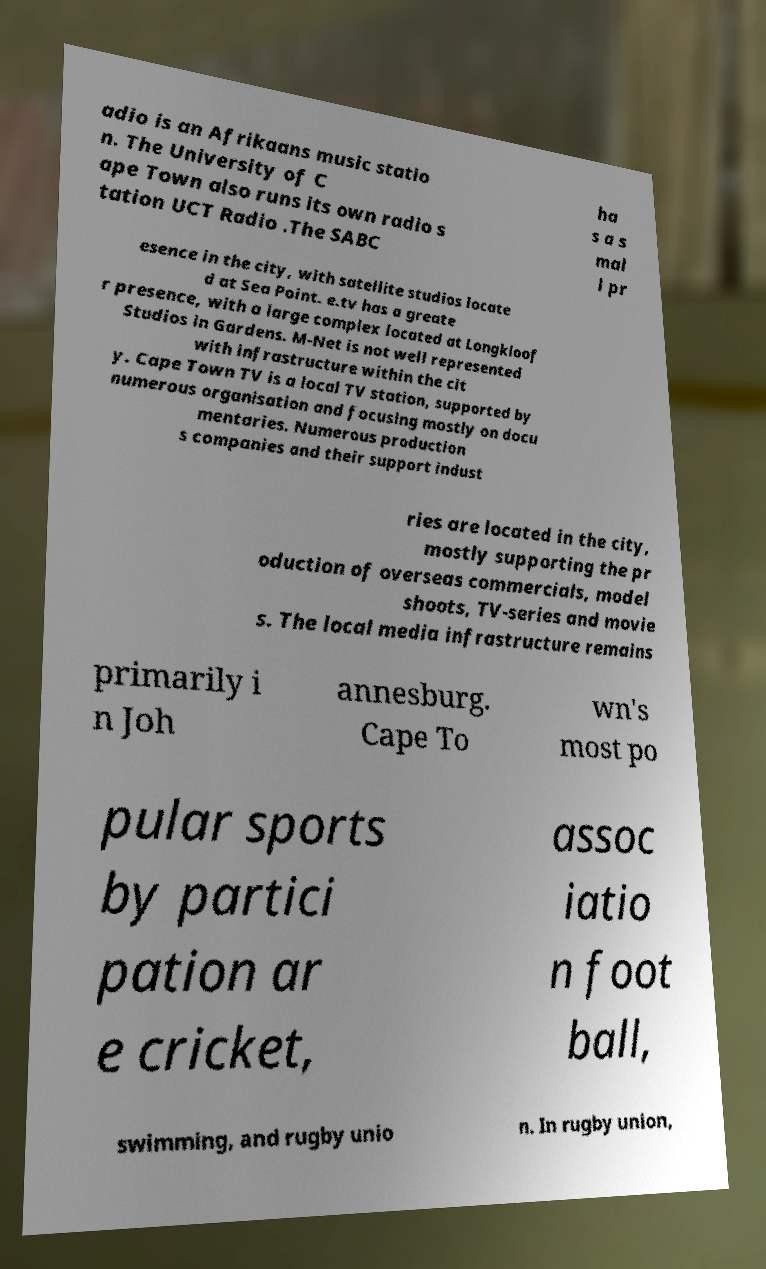For documentation purposes, I need the text within this image transcribed. Could you provide that? adio is an Afrikaans music statio n. The University of C ape Town also runs its own radio s tation UCT Radio .The SABC ha s a s mal l pr esence in the city, with satellite studios locate d at Sea Point. e.tv has a greate r presence, with a large complex located at Longkloof Studios in Gardens. M-Net is not well represented with infrastructure within the cit y. Cape Town TV is a local TV station, supported by numerous organisation and focusing mostly on docu mentaries. Numerous production s companies and their support indust ries are located in the city, mostly supporting the pr oduction of overseas commercials, model shoots, TV-series and movie s. The local media infrastructure remains primarily i n Joh annesburg. Cape To wn's most po pular sports by partici pation ar e cricket, assoc iatio n foot ball, swimming, and rugby unio n. In rugby union, 